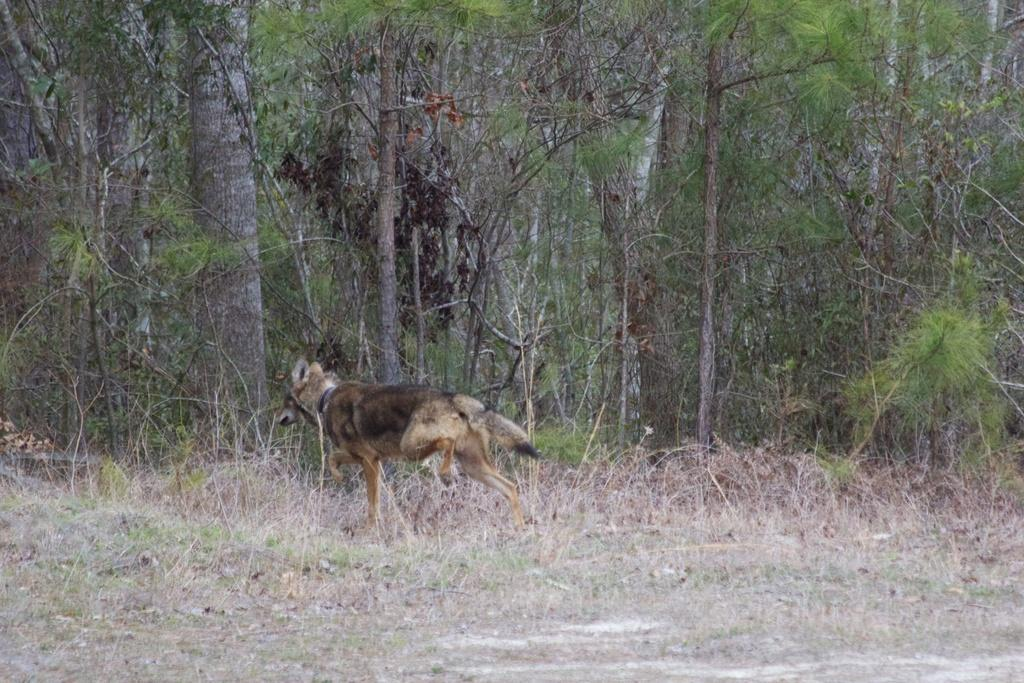What type of creature can be seen in the image? There is an animal in the image. Where is the animal located? The animal is on the ground. What can be seen in the background of the image? There are trees in the background of the image. How many nuts can be seen in the image? There are no nuts present in the image. What type of care is the animal receiving in the image? There is no indication of care being provided to the animal in the image. 